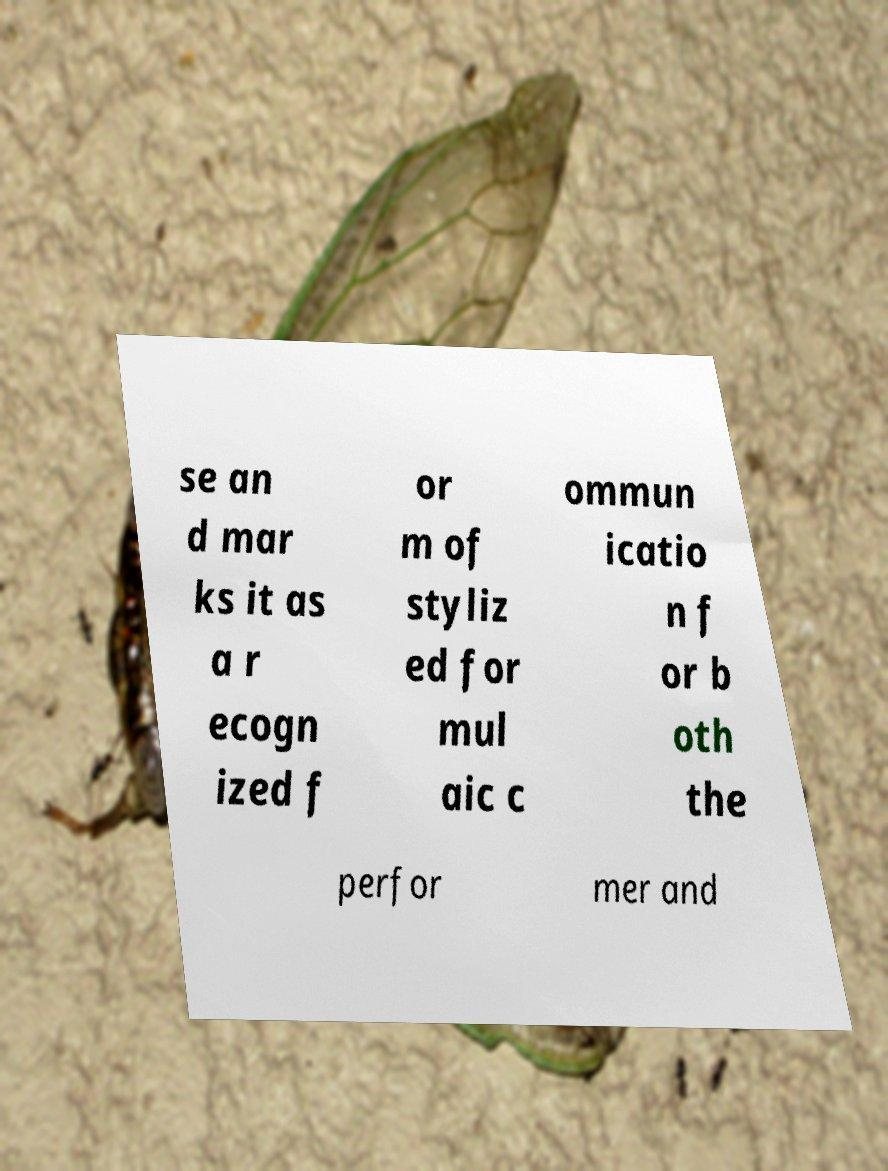There's text embedded in this image that I need extracted. Can you transcribe it verbatim? se an d mar ks it as a r ecogn ized f or m of styliz ed for mul aic c ommun icatio n f or b oth the perfor mer and 